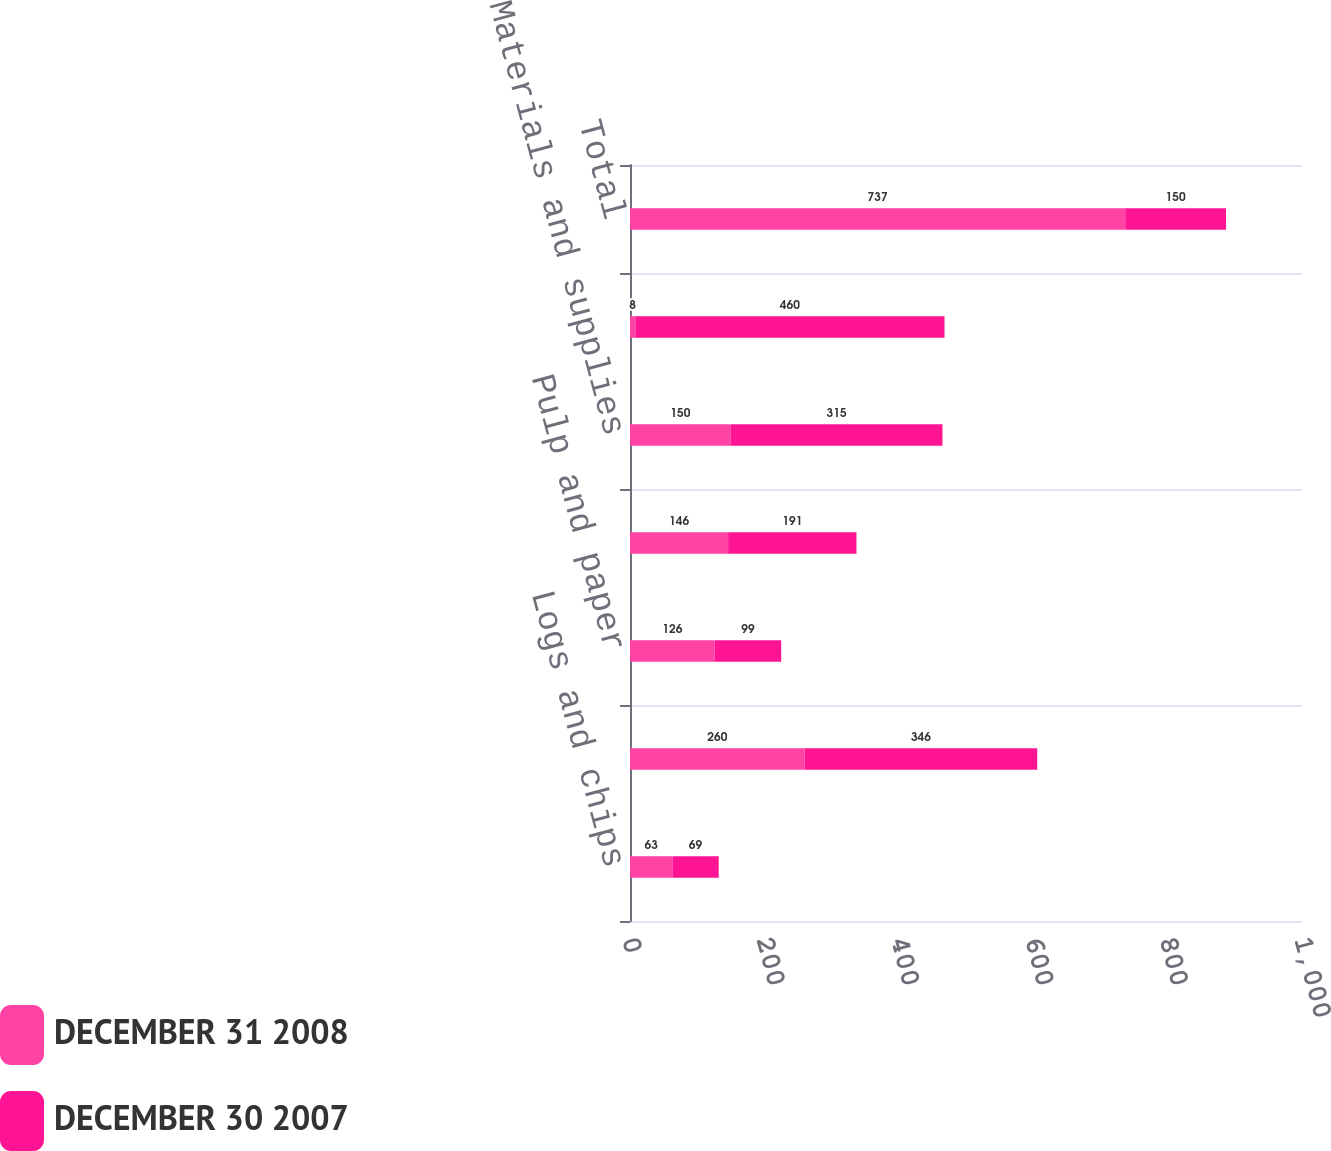Convert chart. <chart><loc_0><loc_0><loc_500><loc_500><stacked_bar_chart><ecel><fcel>Logs and chips<fcel>Lumber plywood panels and<fcel>Pulp and paper<fcel>Other products<fcel>Materials and supplies<fcel>Less discontinued operations<fcel>Total<nl><fcel>DECEMBER 31 2008<fcel>63<fcel>260<fcel>126<fcel>146<fcel>150<fcel>8<fcel>737<nl><fcel>DECEMBER 30 2007<fcel>69<fcel>346<fcel>99<fcel>191<fcel>315<fcel>460<fcel>150<nl></chart> 